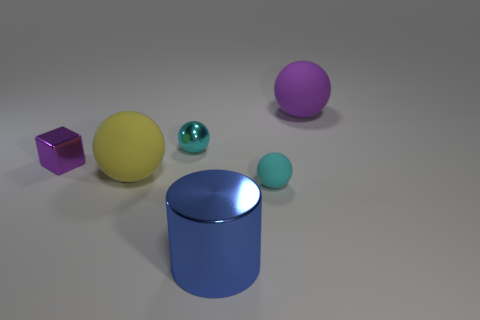Subtract all yellow balls. How many balls are left? 3 Add 2 small brown objects. How many objects exist? 8 Add 6 large yellow things. How many large yellow things exist? 7 Subtract all yellow balls. How many balls are left? 3 Subtract 0 gray balls. How many objects are left? 6 Subtract all cubes. How many objects are left? 5 Subtract 1 cylinders. How many cylinders are left? 0 Subtract all blue spheres. Subtract all purple blocks. How many spheres are left? 4 Subtract all red balls. How many green cylinders are left? 0 Subtract all purple shiny blocks. Subtract all large purple rubber spheres. How many objects are left? 4 